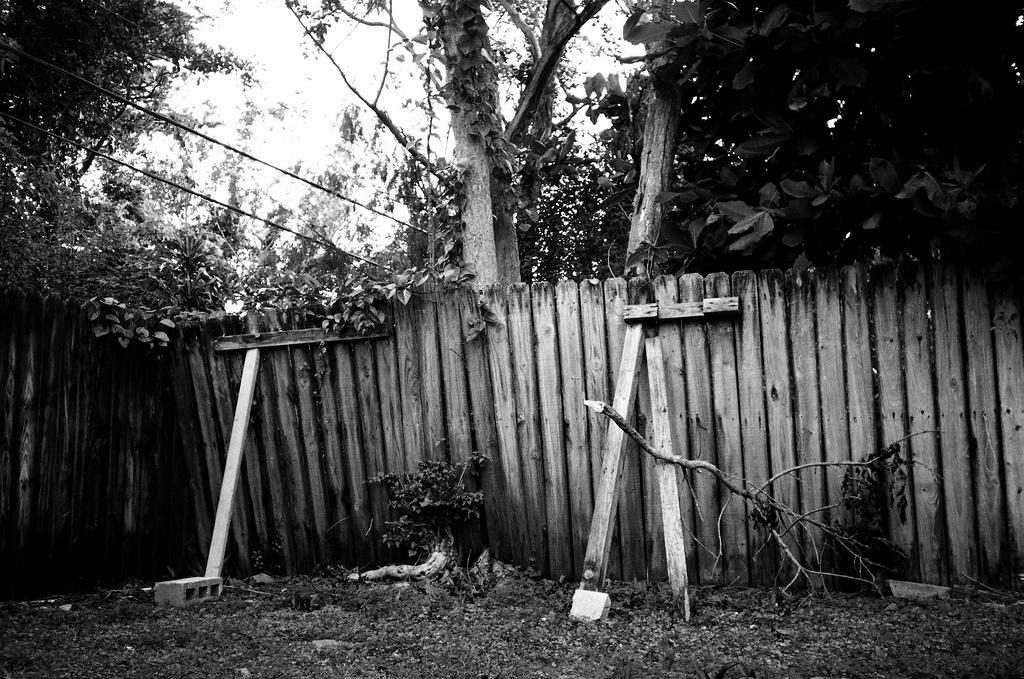What type of material is used for the wall in the image? There is a wooden wall in the image. What type of vegetation is present in the image? There are trees in the image. What part of the natural environment is visible in the image? The sky is visible in the image. What hobbies are the trees participating in within the image? Trees do not have hobbies, as they are inanimate objects. 